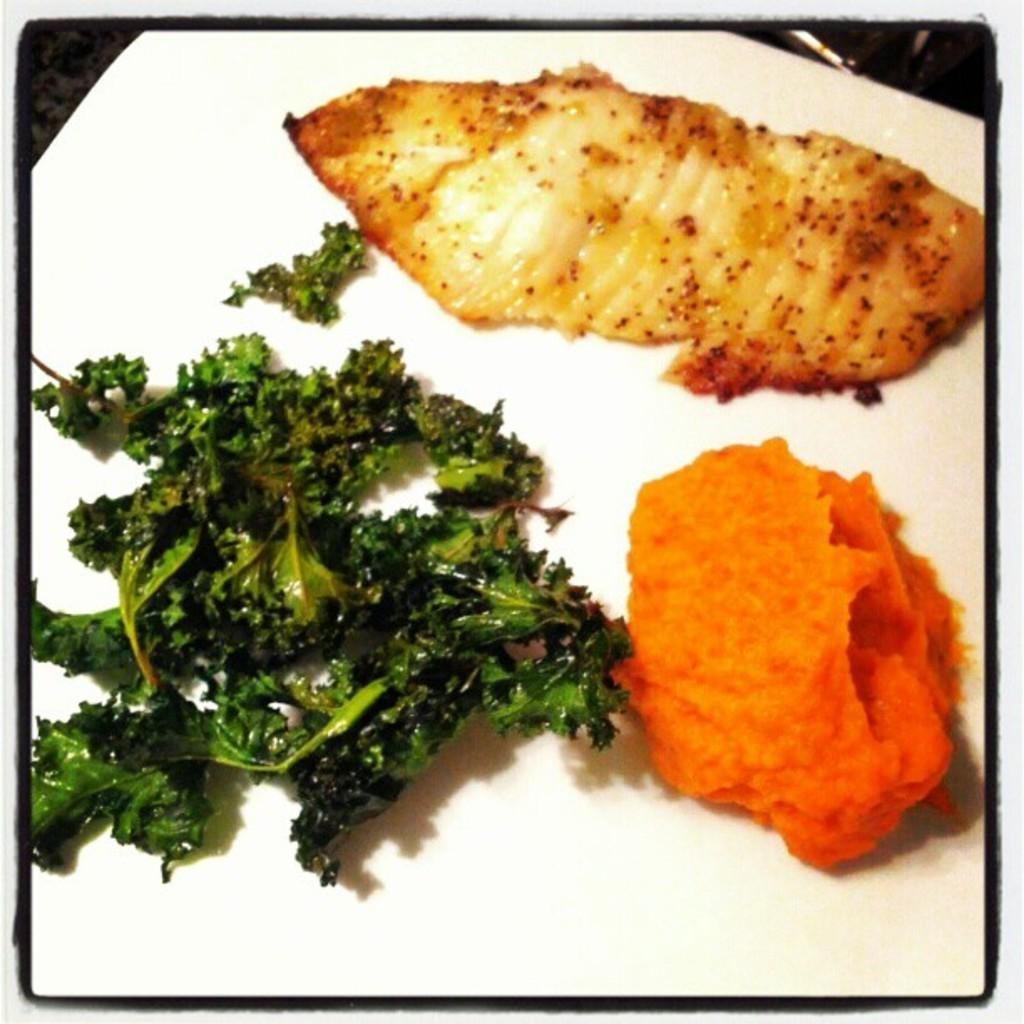Describe this image in one or two sentences. In this image I can see some food items on the white surface. 